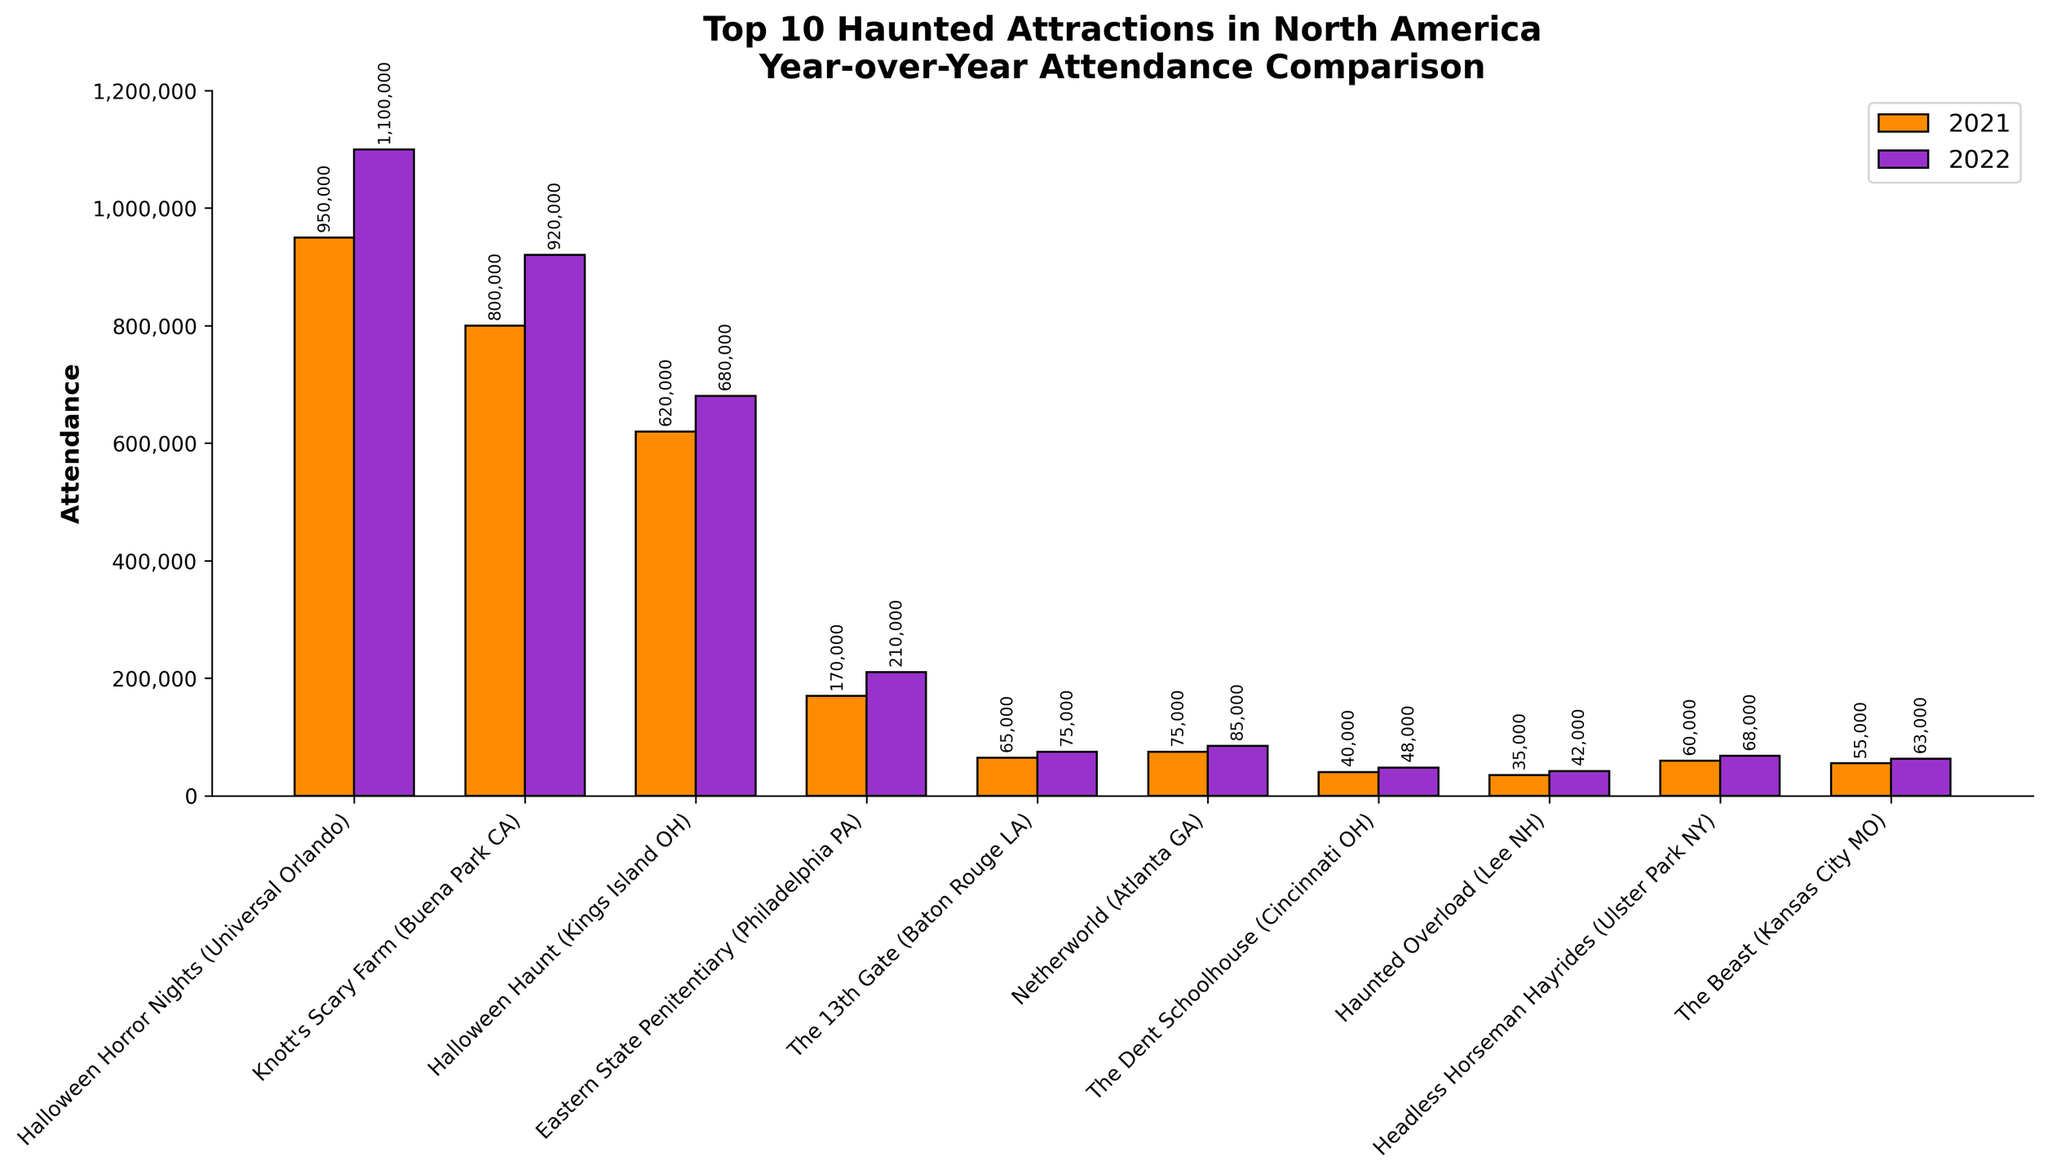What is the difference in attendance between the top attraction in 2022 and the top attraction in 2021? In 2022, the top attraction is Halloween Horror Nights with 1,100,000 attendees, and in 2021, it is also Halloween Horror Nights with 950,000 attendees. The difference in attendance is 1,100,000 - 950,000 = 150,000.
Answer: 150,000 Which attraction had the highest increase in attendance from 2021 to 2022? By comparing the increase in attendance for each attraction, we see that Halloween Horror Nights increased by 1,100,000 - 950,000 = 150,000, which is the highest increase among all attractions.
Answer: Halloween Horror Nights Which attractions had less than 100,000 attendees in both 2021 and 2022? From the bar chart, The 13th Gate, Netherworld, The Dent Schoolhouse, Haunted Overload, Headless Horseman Hayrides, and The Beast all had less than 100,000 attendees in both years.
Answer: The 13th Gate, Netherworld, The Dent Schoolhouse, Haunted Overload, Headless Horseman Hayrides, The Beast What is the total attendance for all attractions in 2021? Adding the attendance figures for all attractions in 2021: 950,000 + 800,000 + 620,000 + 170,000 + 65,000 + 75,000 + 40,000 + 35,000 + 60,000 + 55,000 = 2,870,000.
Answer: 2,870,000 Which attractions experienced a decrease in attendance from 2021 to 2022? According to the bar chart, none of the attractions experienced a decrease in attendance from 2021 to 2022; all attractions either maintained or increased their attendance.
Answer: None How many attractions had more than 500,000 attendees in 2022? The bar chart shows three attractions with more than 500,000 attendees in 2022: Halloween Horror Nights, Knott's Scary Farm, and Halloween Haunt.
Answer: 3 What is the average attendance for the top 10 attractions in 2022? Adding the attendance for all attractions in 2022 and dividing by 10: (1,100,000 + 920,000 + 680,000 + 210,000 + 75,000 + 85,000 + 48,000 + 42,000 + 68,000 + 63,000) / 10 = 3,291,000 / 10 = 329,100.
Answer: 329,100 Which attraction had exactly 75,000 attendees in 2022? The bar chart indicates that The 13th Gate had exactly 75,000 attendees in 2022.
Answer: The 13th Gate 